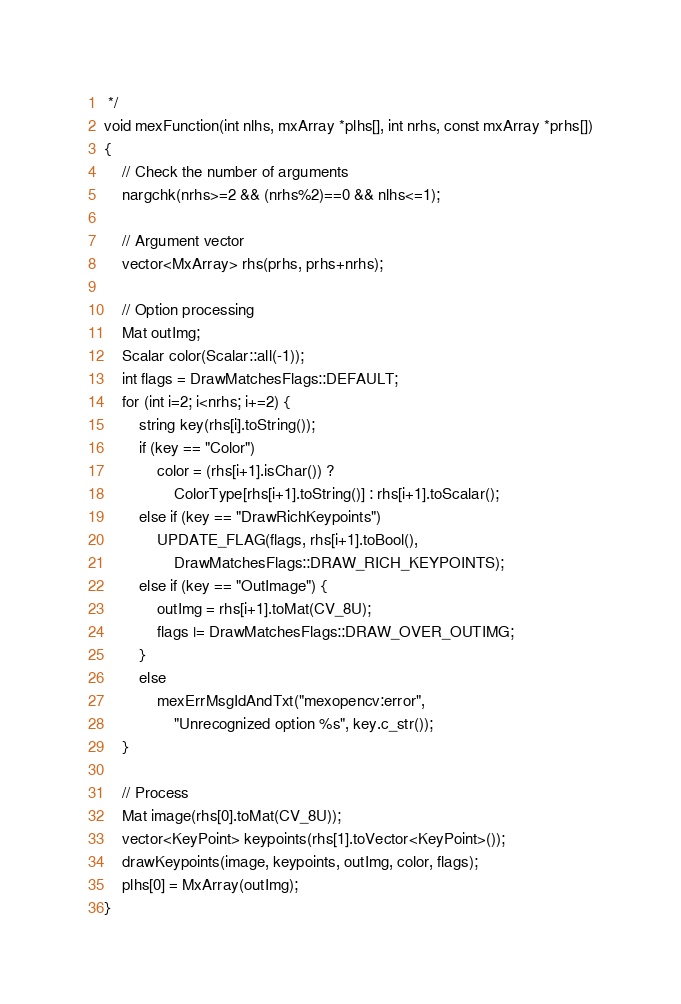Convert code to text. <code><loc_0><loc_0><loc_500><loc_500><_C++_> */
void mexFunction(int nlhs, mxArray *plhs[], int nrhs, const mxArray *prhs[])
{
    // Check the number of arguments
    nargchk(nrhs>=2 && (nrhs%2)==0 && nlhs<=1);

    // Argument vector
    vector<MxArray> rhs(prhs, prhs+nrhs);

    // Option processing
    Mat outImg;
    Scalar color(Scalar::all(-1));
    int flags = DrawMatchesFlags::DEFAULT;
    for (int i=2; i<nrhs; i+=2) {
        string key(rhs[i].toString());
        if (key == "Color")
            color = (rhs[i+1].isChar()) ?
                ColorType[rhs[i+1].toString()] : rhs[i+1].toScalar();
        else if (key == "DrawRichKeypoints")
            UPDATE_FLAG(flags, rhs[i+1].toBool(),
                DrawMatchesFlags::DRAW_RICH_KEYPOINTS);
        else if (key == "OutImage") {
            outImg = rhs[i+1].toMat(CV_8U);
            flags |= DrawMatchesFlags::DRAW_OVER_OUTIMG;
        }
        else
            mexErrMsgIdAndTxt("mexopencv:error",
                "Unrecognized option %s", key.c_str());
    }

    // Process
    Mat image(rhs[0].toMat(CV_8U));
    vector<KeyPoint> keypoints(rhs[1].toVector<KeyPoint>());
    drawKeypoints(image, keypoints, outImg, color, flags);
    plhs[0] = MxArray(outImg);
}
</code> 